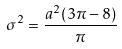<formula> <loc_0><loc_0><loc_500><loc_500>\sigma ^ { 2 } = \frac { a ^ { 2 } ( 3 \pi - 8 ) } { \pi }</formula> 